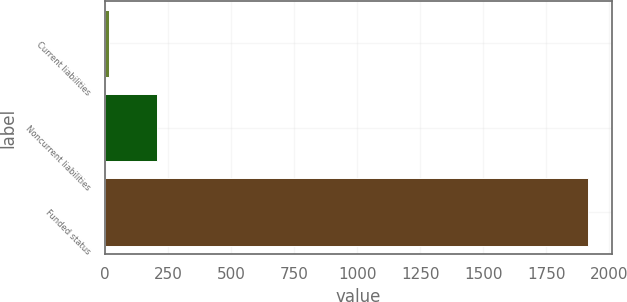Convert chart. <chart><loc_0><loc_0><loc_500><loc_500><bar_chart><fcel>Current liabilities<fcel>Noncurrent liabilities<fcel>Funded status<nl><fcel>17<fcel>206.7<fcel>1914<nl></chart> 